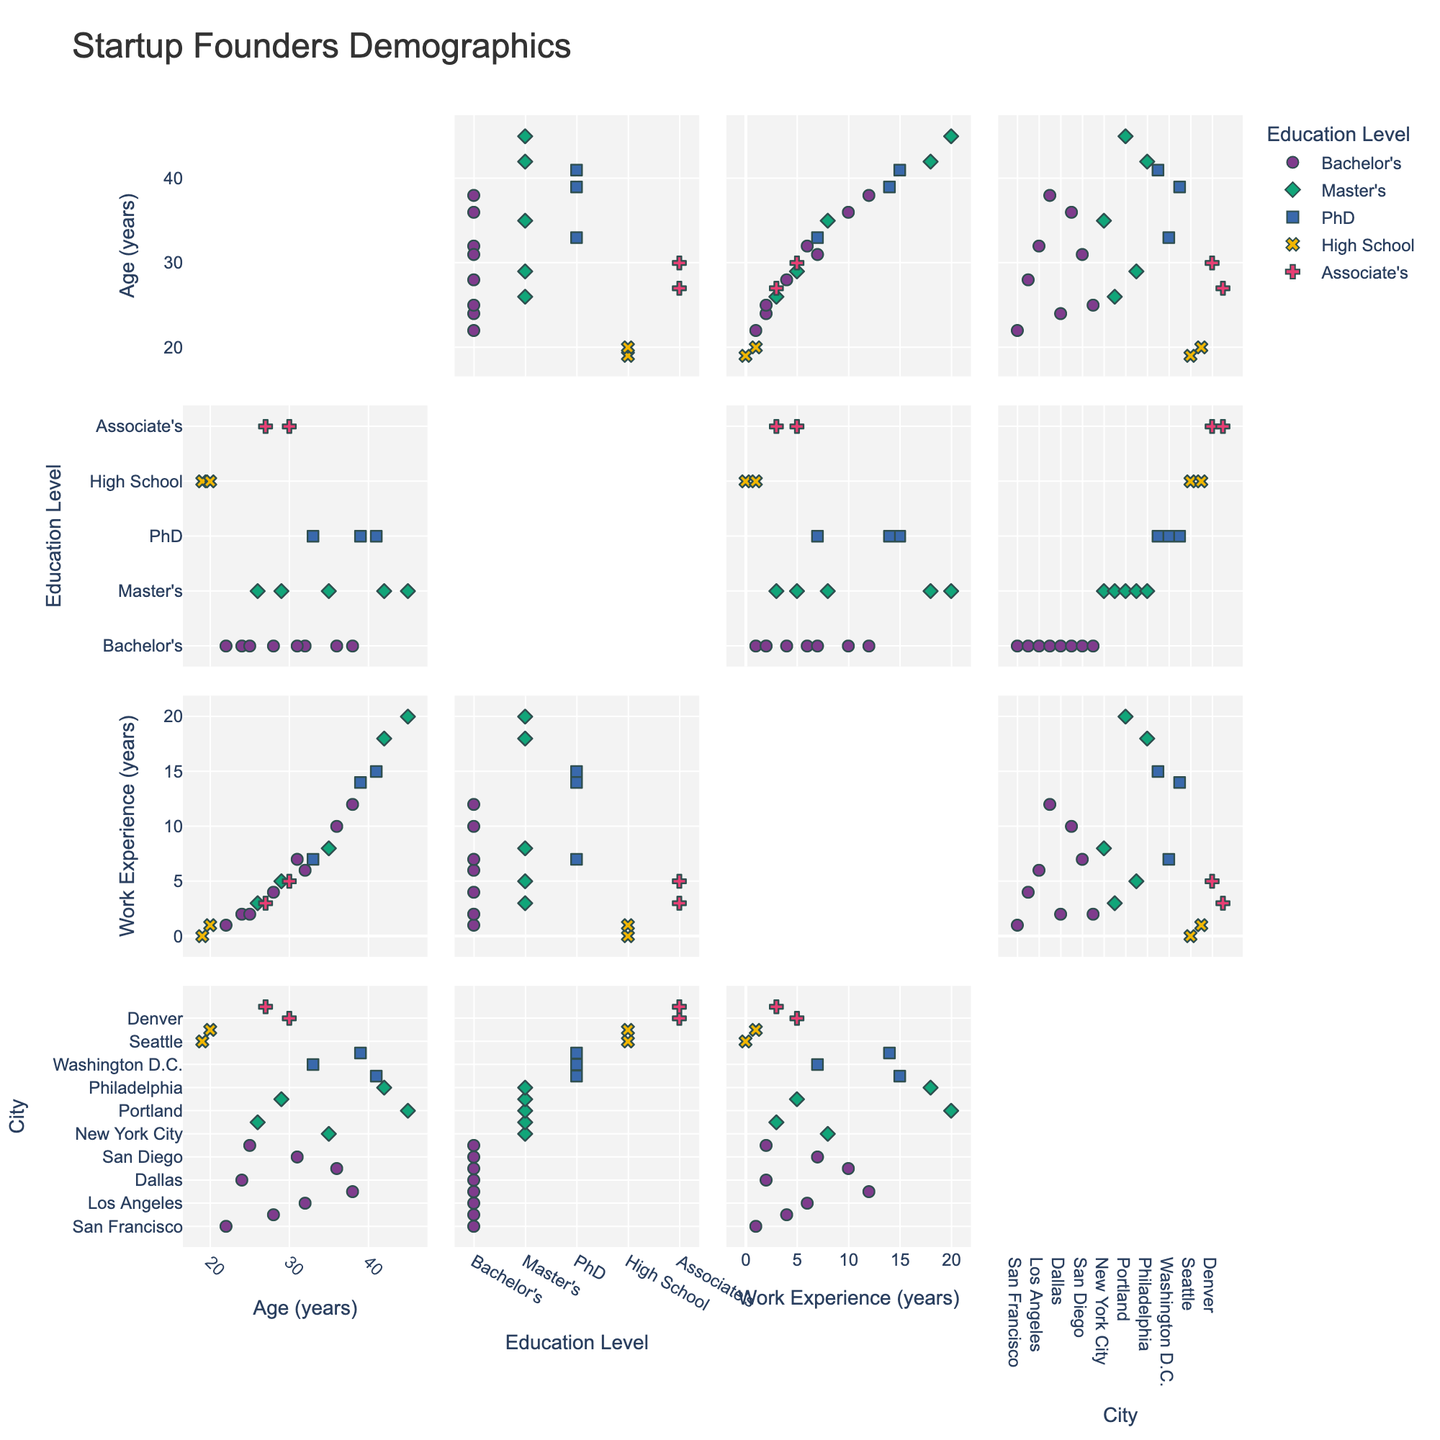What is the title of the scatterplot matrix? The title of the scatterplot matrix is displayed at the top of the figure. It is a textual element usually set by the creator to describe the overall theme of the data being visualized.
Answer: Startup Founders Demographics How many dimensions are plotted in the scatterplot matrix? The plot shows multiple scatterplots, each representing a pairwise relationship among the variables. The title mentions the dimensions and they correspond to the columns 'Age', 'Education', 'Experience', and 'Location'.
Answer: 4 Which education level has the most data points, and how many are there? By observing the scatterplot matrix and counting the markers, we can tally the number of occurrences for each education level category.
Answer: Bachelor's, 9 Which location appears with founders who have less than 3 years of experience? Identify the points that have 'Experience' less than 3 years and then check the associated 'Location' values. The scatterplot matrix plots these dimensions against each other.
Answer: Seattle, Dallas, Las Vegas What is the range of ages plotted in the scatterplot matrix? The range of ages can be determined by finding the minimum and maximum values on the 'Age' axes across the scatterplots. The scatterplot matrix layout typically shows these bounds.
Answer: 19 to 45 years Which data points have both high work experience (more than 15 years) and a PhD? List their locations. Look at the data points that fall in the 'Experience' range above 15 years and have a PhD; their locations are marked on the scatter matrix.
Answer: Boston, Philadelphia What is the average age of founders with a Master's degree? Locate the data points with a 'Master's' level of education and then average their 'Age' values. Sum the ages and divide by the count of such data points.
Answer: (35 + 26 + 29 + 45 + 42)/5 = 177/5 = 35.4 Compare the work experience of founders in New York City and Miami. Who has more experience? Find the data points corresponding to New York City and Miami. Compare the 'Experience' values from these data points directly.
Answer: NY: 8, Miami: 12, so Miami Which educational level shows the widest age range? For each education level, compute the range by subtracting the minimum age from the maximum age within that category. Compare results to identify the widest range.
Answer: PhD (33 to 41 and 39) which is 41 (max) - 33 (min) = 8 years 